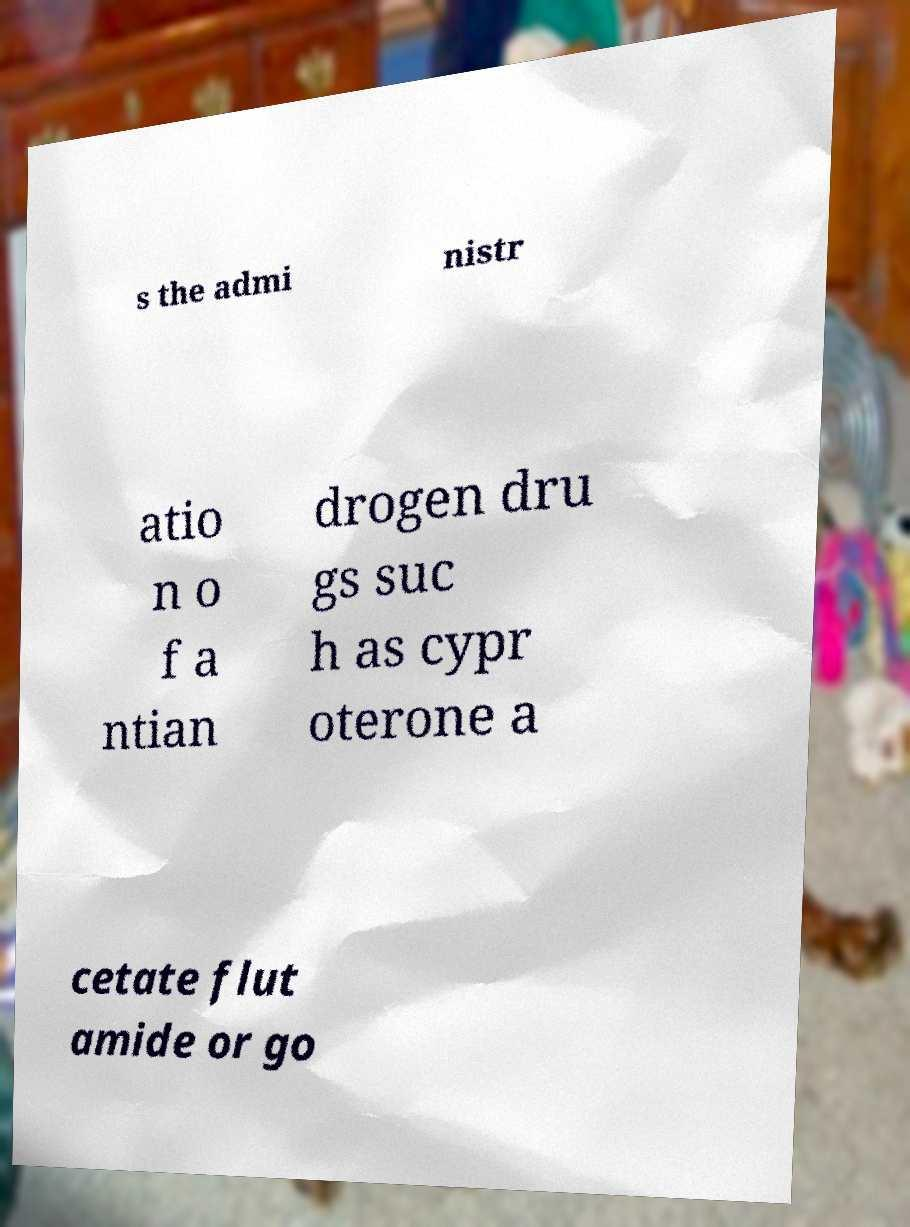Please identify and transcribe the text found in this image. s the admi nistr atio n o f a ntian drogen dru gs suc h as cypr oterone a cetate flut amide or go 